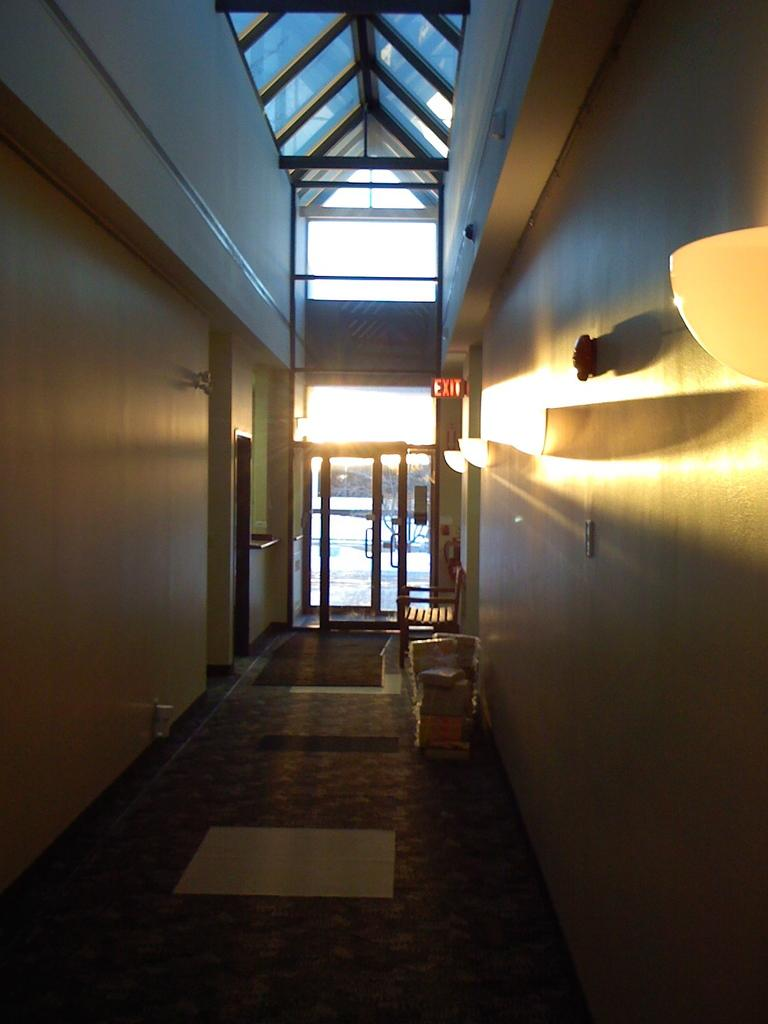What type of structure can be seen in the image? There is architecture in the image. Where are the lights located in the image? The lights are on the right side of the image. What type of polish is being applied to the top of the garden in the image? There is no mention of polish, a top, or a garden in the image. 